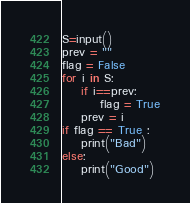Convert code to text. <code><loc_0><loc_0><loc_500><loc_500><_Python_>S=input()
prev = ""
flag = False
for i in S:
    if i==prev:
        flag = True
    prev = i
if flag == True :
    print("Bad")
else:
    print("Good")</code> 